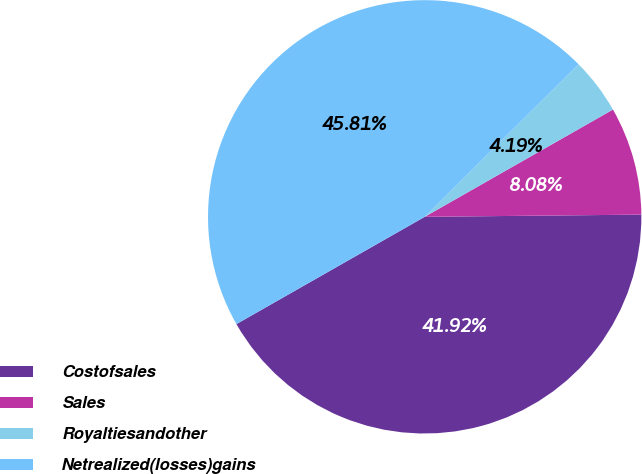<chart> <loc_0><loc_0><loc_500><loc_500><pie_chart><fcel>Costofsales<fcel>Sales<fcel>Royaltiesandother<fcel>Netrealized(losses)gains<nl><fcel>41.92%<fcel>8.08%<fcel>4.19%<fcel>45.81%<nl></chart> 